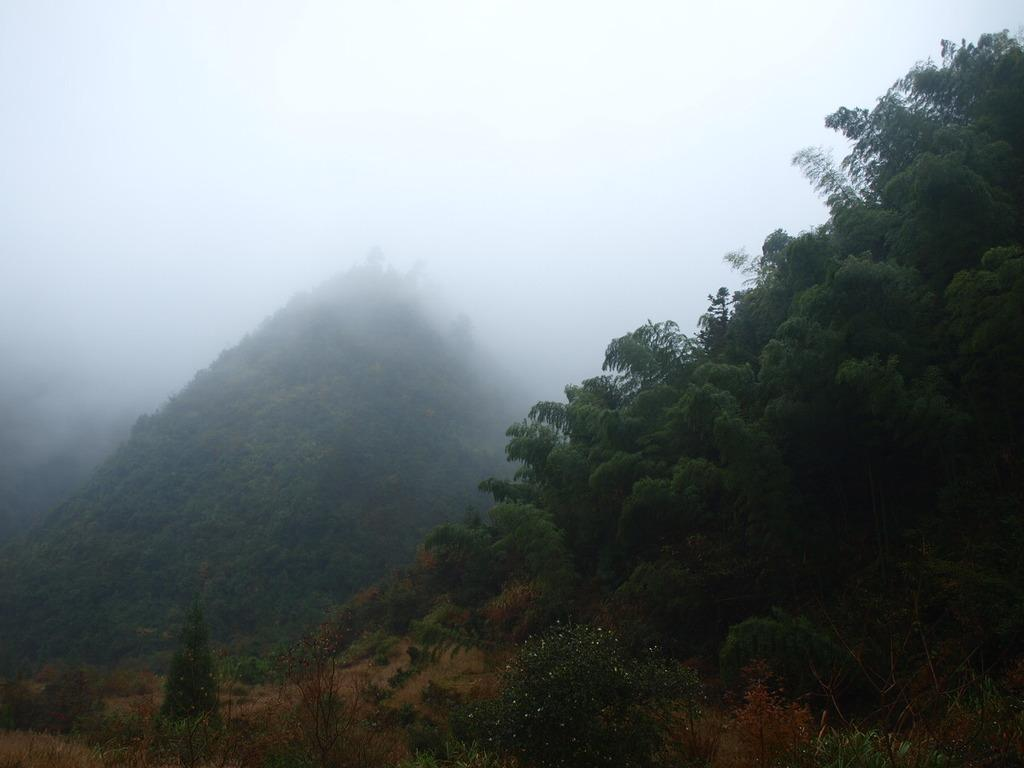What type of vegetation is located on the bottom right side of the image? There are trees on the bottom right side of the image. What geographical feature is present on the bottom left side of the image? There is a hill on the bottom left side of the image. What atmospheric condition is visible at the top of the image? There is fog at the top of the image. What type of creature is providing advice in the image? There is no creature present in the image, and therefore no advice is being given. What type of harmony can be observed between the trees and the hill in the image? The image does not depict any interaction or relationship between the trees and the hill, so it is not possible to determine any harmony between them. 